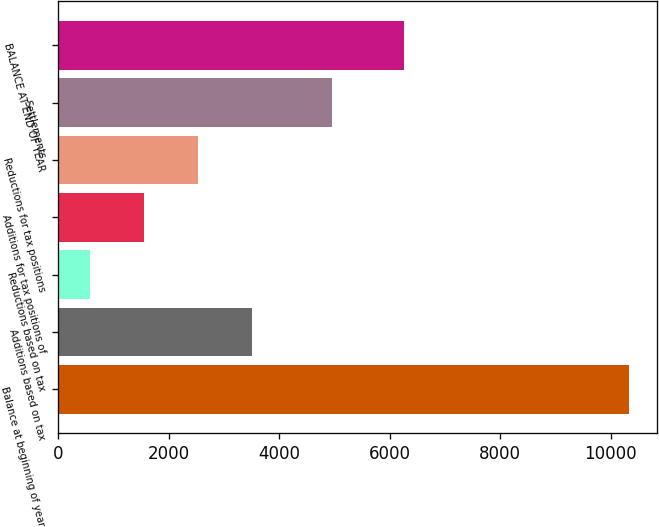Convert chart. <chart><loc_0><loc_0><loc_500><loc_500><bar_chart><fcel>Balance at beginning of year<fcel>Additions based on tax<fcel>Reductions based on tax<fcel>Additions for tax positions of<fcel>Reductions for tax positions<fcel>Settlements<fcel>BALANCE AT END OF YEAR<nl><fcel>10322<fcel>3503.3<fcel>581<fcel>1555.1<fcel>2529.2<fcel>4961<fcel>6262<nl></chart> 